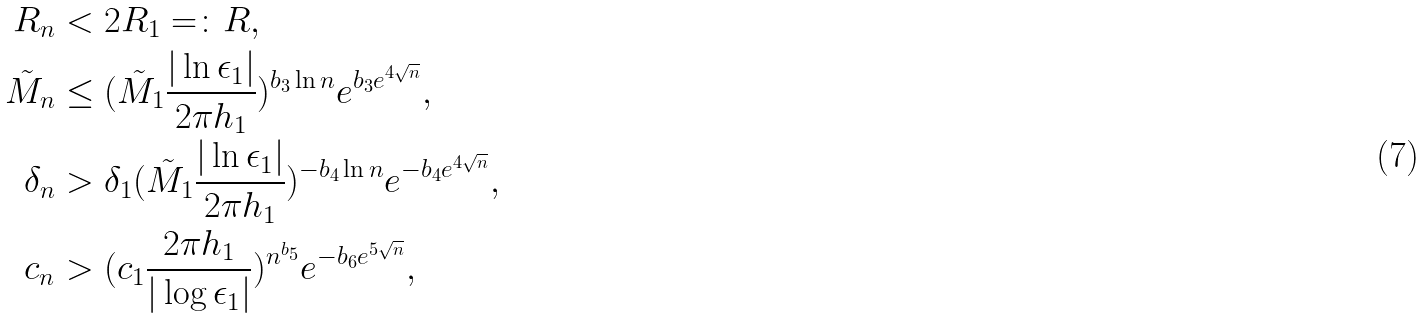<formula> <loc_0><loc_0><loc_500><loc_500>R _ { n } & < 2 R _ { 1 } = \colon R , \\ \tilde { M } _ { n } & \leq ( \tilde { M } _ { 1 } \frac { | \ln \epsilon _ { 1 } | } { 2 \pi h _ { 1 } } ) ^ { b _ { 3 } \ln n } e ^ { b _ { 3 } e ^ { 4 \sqrt { n } } } , \\ \delta _ { n } & > \delta _ { 1 } ( \tilde { M } _ { 1 } \frac { | \ln \epsilon _ { 1 } | } { 2 \pi h _ { 1 } } ) ^ { - b _ { 4 } \ln n } e ^ { - b _ { 4 } e ^ { 4 \sqrt { n } } } , \\ c _ { n } & > ( c _ { 1 } \frac { 2 \pi h _ { 1 } } { | \log \epsilon _ { 1 } | } ) ^ { n ^ { b _ { 5 } } } e ^ { - b _ { 6 } e ^ { 5 \sqrt { n } } } ,</formula> 